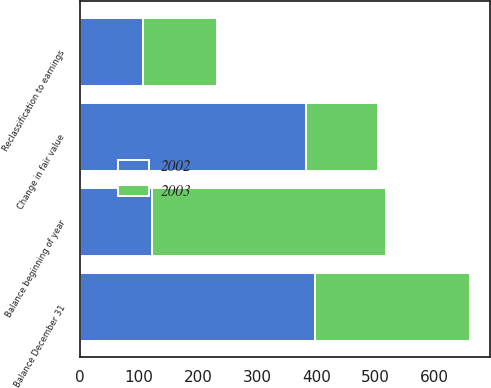Convert chart to OTSL. <chart><loc_0><loc_0><loc_500><loc_500><stacked_bar_chart><ecel><fcel>Balance beginning of year<fcel>Reclassification to earnings<fcel>Change in fair value<fcel>Balance December 31<nl><fcel>2003<fcel>398<fcel>126<fcel>121<fcel>263<nl><fcel>2002<fcel>121<fcel>106<fcel>383<fcel>398<nl></chart> 